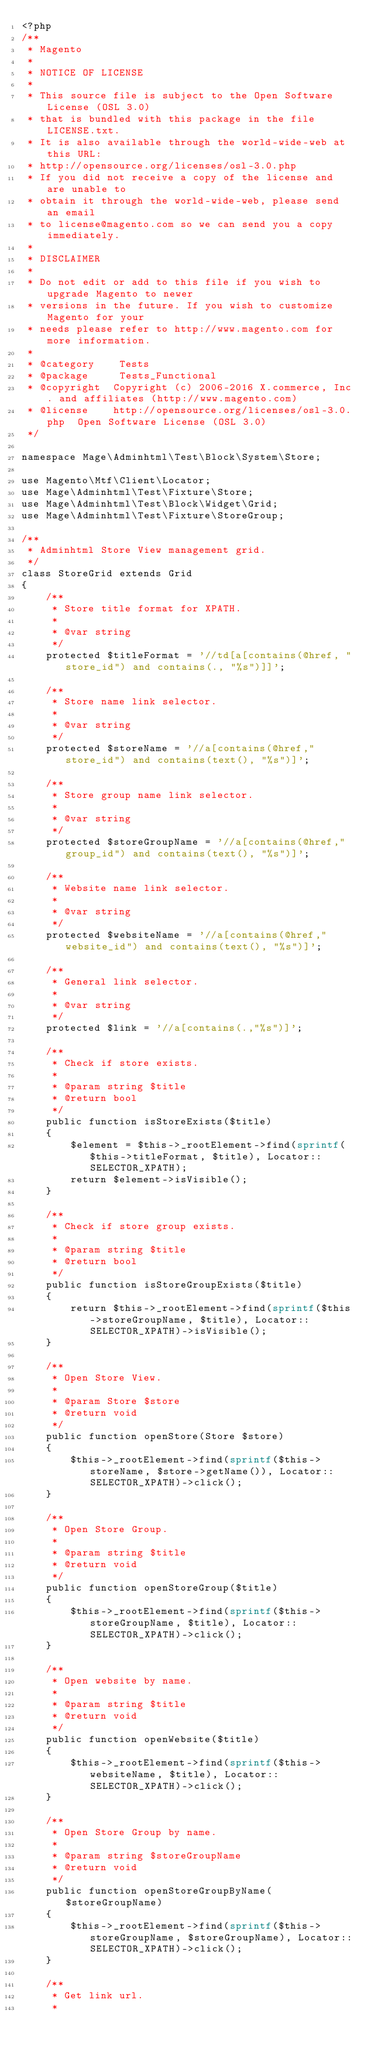Convert code to text. <code><loc_0><loc_0><loc_500><loc_500><_PHP_><?php
/**
 * Magento
 *
 * NOTICE OF LICENSE
 *
 * This source file is subject to the Open Software License (OSL 3.0)
 * that is bundled with this package in the file LICENSE.txt.
 * It is also available through the world-wide-web at this URL:
 * http://opensource.org/licenses/osl-3.0.php
 * If you did not receive a copy of the license and are unable to
 * obtain it through the world-wide-web, please send an email
 * to license@magento.com so we can send you a copy immediately.
 *
 * DISCLAIMER
 *
 * Do not edit or add to this file if you wish to upgrade Magento to newer
 * versions in the future. If you wish to customize Magento for your
 * needs please refer to http://www.magento.com for more information.
 *
 * @category    Tests
 * @package     Tests_Functional
 * @copyright  Copyright (c) 2006-2016 X.commerce, Inc. and affiliates (http://www.magento.com)
 * @license    http://opensource.org/licenses/osl-3.0.php  Open Software License (OSL 3.0)
 */

namespace Mage\Adminhtml\Test\Block\System\Store;

use Magento\Mtf\Client\Locator;
use Mage\Adminhtml\Test\Fixture\Store;
use Mage\Adminhtml\Test\Block\Widget\Grid;
use Mage\Adminhtml\Test\Fixture\StoreGroup;

/**
 * Adminhtml Store View management grid.
 */
class StoreGrid extends Grid
{
    /**
     * Store title format for XPATH.
     *
     * @var string
     */
    protected $titleFormat = '//td[a[contains(@href, "store_id") and contains(., "%s")]]';

    /**
     * Store name link selector.
     *
     * @var string
     */
    protected $storeName = '//a[contains(@href,"store_id") and contains(text(), "%s")]';

    /**
     * Store group name link selector.
     *
     * @var string
     */
    protected $storeGroupName = '//a[contains(@href,"group_id") and contains(text(), "%s")]';

    /**
     * Website name link selector.
     *
     * @var string
     */
    protected $websiteName = '//a[contains(@href,"website_id") and contains(text(), "%s")]';

    /**
     * General link selector.
     *
     * @var string
     */
    protected $link = '//a[contains(.,"%s")]';

    /**
     * Check if store exists.
     *
     * @param string $title
     * @return bool
     */
    public function isStoreExists($title)
    {
        $element = $this->_rootElement->find(sprintf($this->titleFormat, $title), Locator::SELECTOR_XPATH);
        return $element->isVisible();
    }

    /**
     * Check if store group exists.
     *
     * @param string $title
     * @return bool
     */
    public function isStoreGroupExists($title)
    {
        return $this->_rootElement->find(sprintf($this->storeGroupName, $title), Locator::SELECTOR_XPATH)->isVisible();
    }

    /**
     * Open Store View.
     *
     * @param Store $store
     * @return void
     */
    public function openStore(Store $store)
    {
        $this->_rootElement->find(sprintf($this->storeName, $store->getName()), Locator::SELECTOR_XPATH)->click();
    }

    /**
     * Open Store Group.
     *
     * @param string $title
     * @return void
     */
    public function openStoreGroup($title)
    {
        $this->_rootElement->find(sprintf($this->storeGroupName, $title), Locator::SELECTOR_XPATH)->click();
    }

    /**
     * Open website by name.
     *
     * @param string $title
     * @return void
     */
    public function openWebsite($title)
    {
        $this->_rootElement->find(sprintf($this->websiteName, $title), Locator::SELECTOR_XPATH)->click();
    }

    /**
     * Open Store Group by name.
     *
     * @param string $storeGroupName
     * @return void
     */
    public function openStoreGroupByName($storeGroupName)
    {
        $this->_rootElement->find(sprintf($this->storeGroupName, $storeGroupName), Locator::SELECTOR_XPATH)->click();
    }

    /**
     * Get link url.
     *</code> 